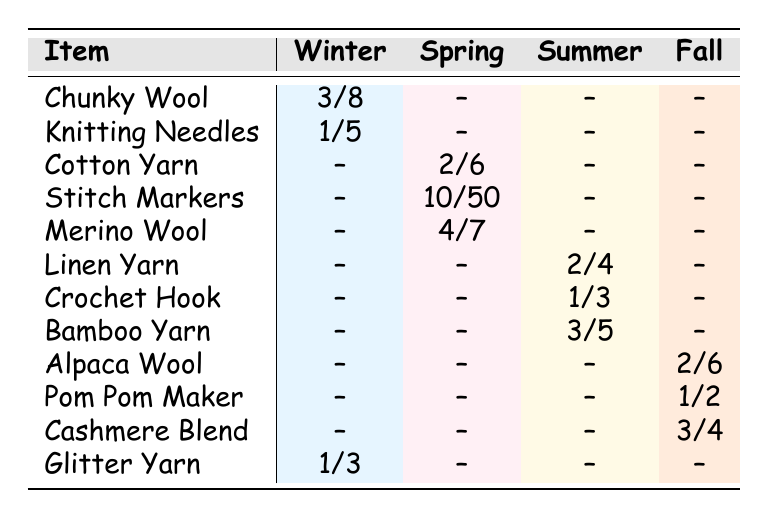What is the quantity of Chunky Wool used in Winter? The table shows that Chunky Wool has a quantity used of 3 in the Winter season.
Answer: 3 How many Knitting Needles are in stock after use in Winter? The quantity in stock for Knitting Needles is 5, and since 1 is used, the remaining stock is 5 - 1 = 4.
Answer: 4 What is the total quantity of all supplies used in Spring? The table shows that the supplies used in Spring are Cotton Yarn (2), Stitch Markers (10), and Merino Wool (4). Summing these gives 2 + 10 + 4 = 16.
Answer: 16 Is there any supply with more than 10 items in stock? The table indicates that Stitch Markers have 50 in stock, which is greater than 10. Therefore, the answer is yes.
Answer: Yes Which season has the most variety of items used? By looking at the table, Winter has 3 items (Chunky Wool, Knitting Needles, Glitter Yarn), Spring has 3 (Cotton Yarn, Stitch Markers, Merino Wool), Summer has 3 (Linen Yarn, Crochet Hook, Bamboo Yarn), and Fall also has 3 (Alpaca Wool, Pom Pom Maker, Cashmere Blend). There is no single season with more variety.
Answer: No What is the total quantity of Glitter Yarn remaining? Glitter Yarn has a quantity used of 1 and a quantity in stock of 3. Thus, the total remaining is 3 - 1 = 2.
Answer: 2 Which item had the highest quantity used in Spring? The highest quantity used in Spring is from Stitch Markers with a quantity of 10, while the others (Cotton Yarn and Merino Wool) used 2 and 4 respectively.
Answer: Stitch Markers How many more items are in stock for Pom Pom Maker compared to Cashmere Blend? The stock for Pom Pom Maker is 2, and for Cashmere Blend, it is 4. Therefore, Cashmere Blend has more stock: 4 - 2 = 2.
Answer: 2 What color is the Bamboo Yarn used in Summer? The table states that Bamboo Yarn is used in Summer and is of the color Sage Green.
Answer: Sage Green 